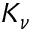Convert formula to latex. <formula><loc_0><loc_0><loc_500><loc_500>K _ { \nu }</formula> 